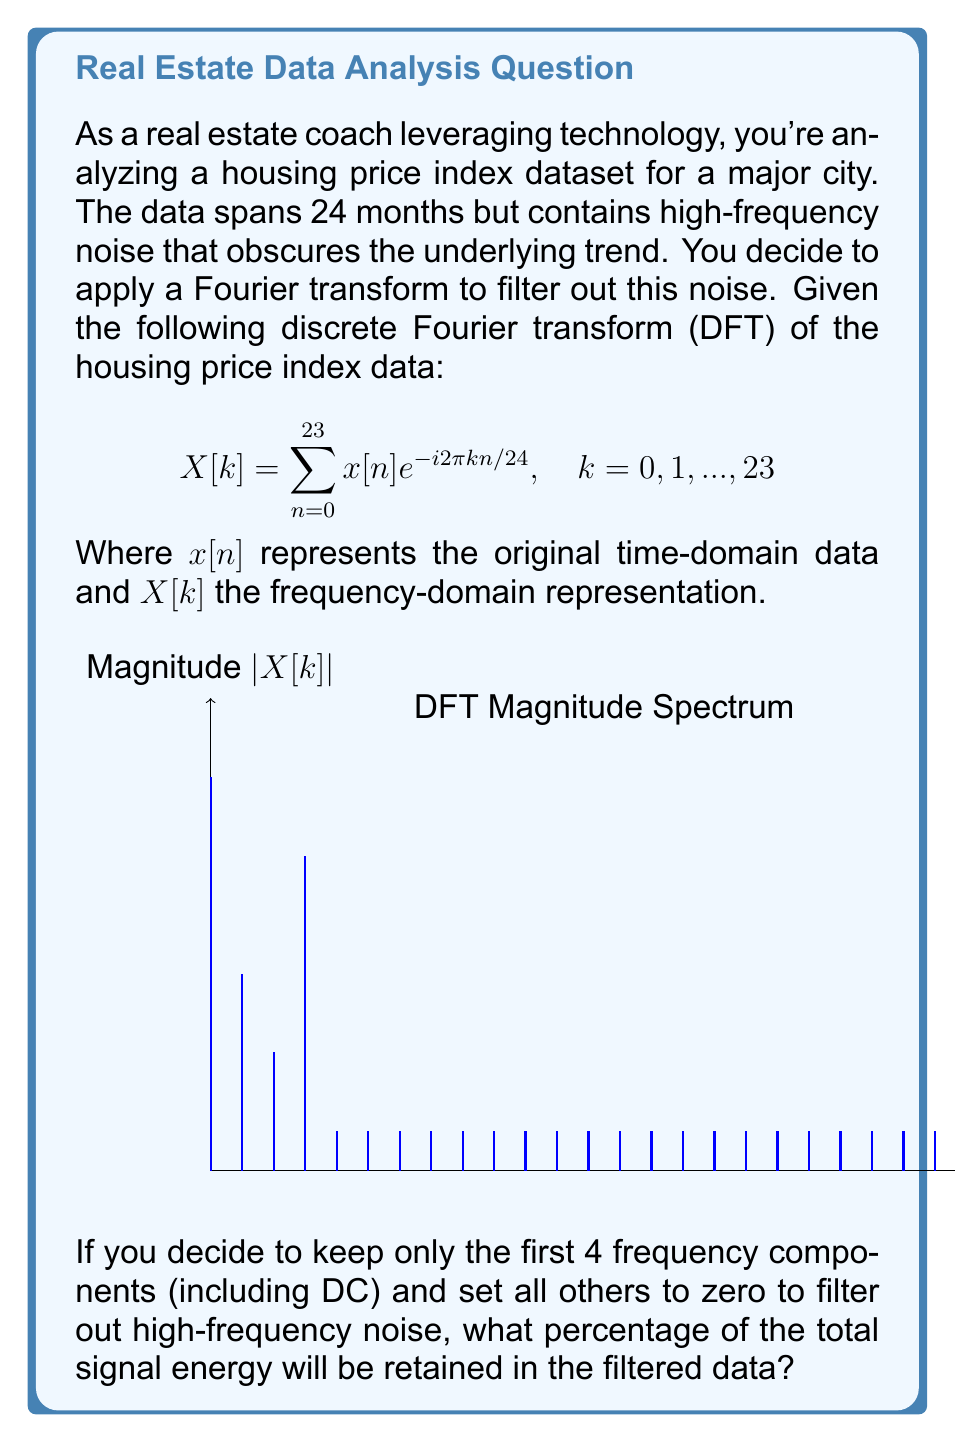Solve this math problem. To solve this problem, we'll follow these steps:

1) The total energy of a discrete signal in the frequency domain is given by Parseval's theorem:

   $$E_{total} = \frac{1}{N}\sum_{k=0}^{N-1} |X[k]|^2$$

   where $N$ is the number of samples (24 in this case).

2) Calculate the total energy:
   $$E_{total} = \frac{1}{24}(100^2 + 50^2 + 30^2 + 80^2 + 20^2 + 10^2 + 5^2 + 3^2 + 2^2 + 15 \times 1^2)$$
   $$E_{total} = \frac{1}{24}(10000 + 2500 + 900 + 6400 + 400 + 100 + 25 + 9 + 4 + 15)$$
   $$E_{total} = \frac{20353}{24} \approx 848.04$$

3) Calculate the energy of the first 4 components:
   $$E_{filtered} = \frac{1}{24}(100^2 + 50^2 + 30^2 + 80^2)$$
   $$E_{filtered} = \frac{1}{24}(10000 + 2500 + 900 + 6400)$$
   $$E_{filtered} = \frac{19800}{24} = 825$$

4) Calculate the percentage of energy retained:
   $$\text{Percentage} = \frac{E_{filtered}}{E_{total}} \times 100\%$$
   $$\text{Percentage} = \frac{825}{848.04} \times 100\% \approx 97.28\%$$

Therefore, by keeping only the first 4 frequency components, approximately 97.28% of the total signal energy will be retained in the filtered data.
Answer: 97.28% 